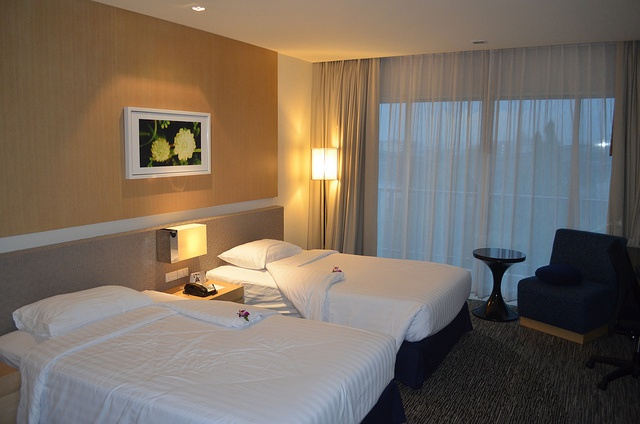Describe the objects in this image and their specific colors. I can see bed in maroon, darkgray, and gray tones, bed in maroon, darkgray, black, tan, and gray tones, couch in maroon, black, gray, and navy tones, and chair in maroon, black, and gray tones in this image. 